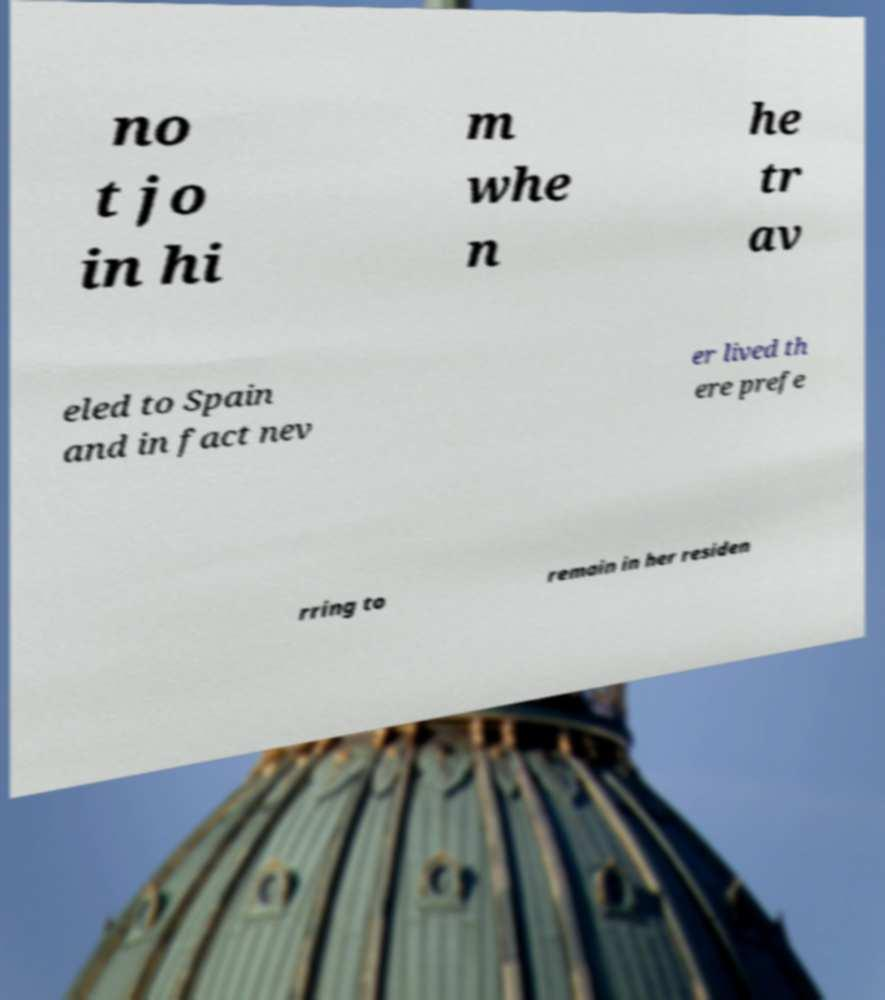Please read and relay the text visible in this image. What does it say? no t jo in hi m whe n he tr av eled to Spain and in fact nev er lived th ere prefe rring to remain in her residen 